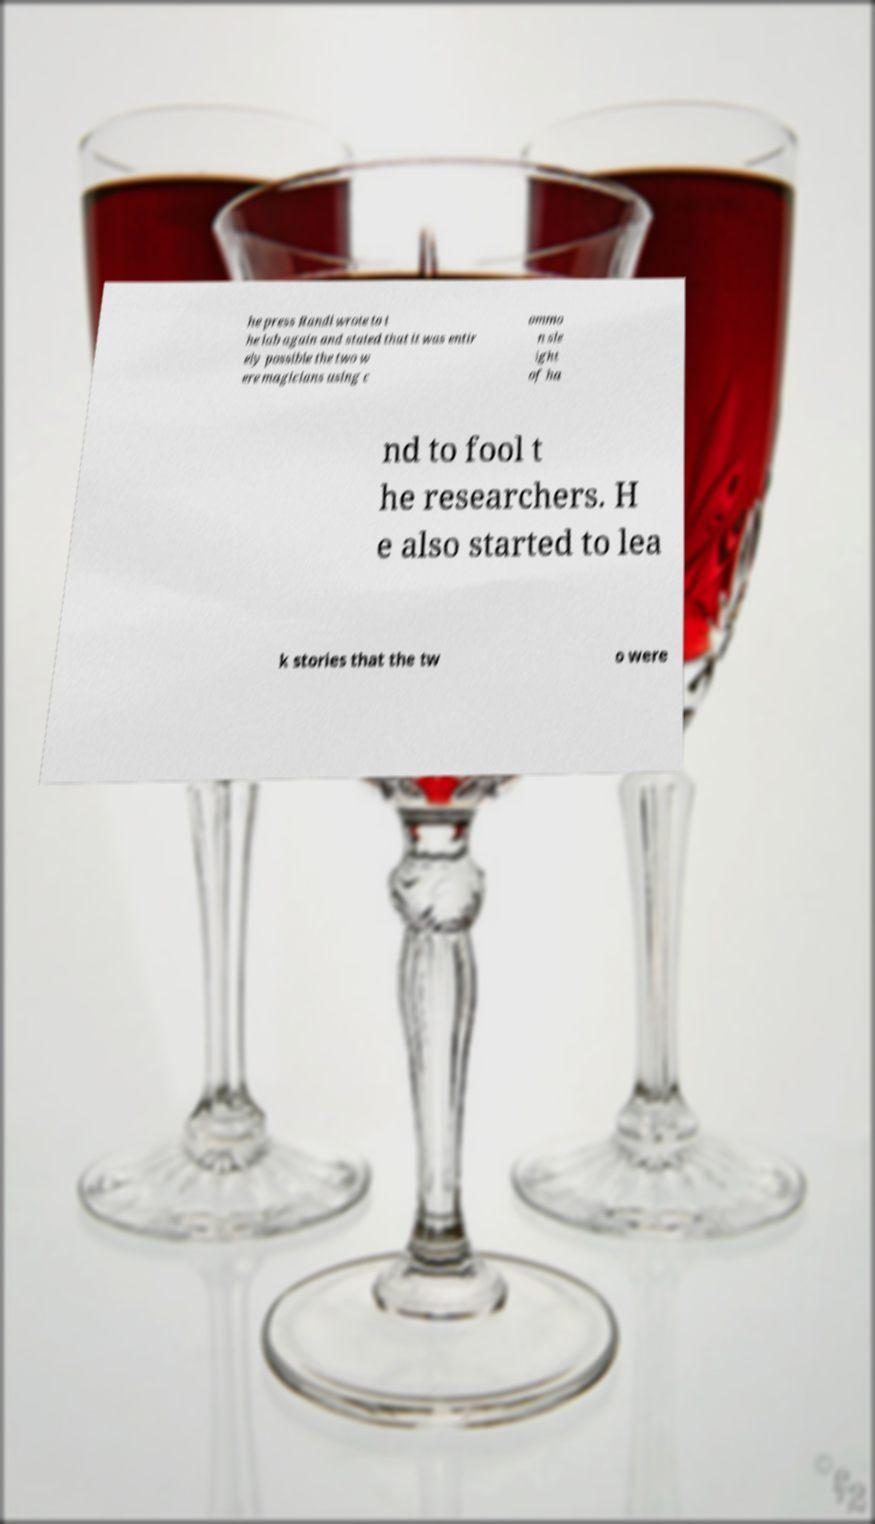Could you extract and type out the text from this image? he press Randi wrote to t he lab again and stated that it was entir ely possible the two w ere magicians using c ommo n sle ight of ha nd to fool t he researchers. H e also started to lea k stories that the tw o were 